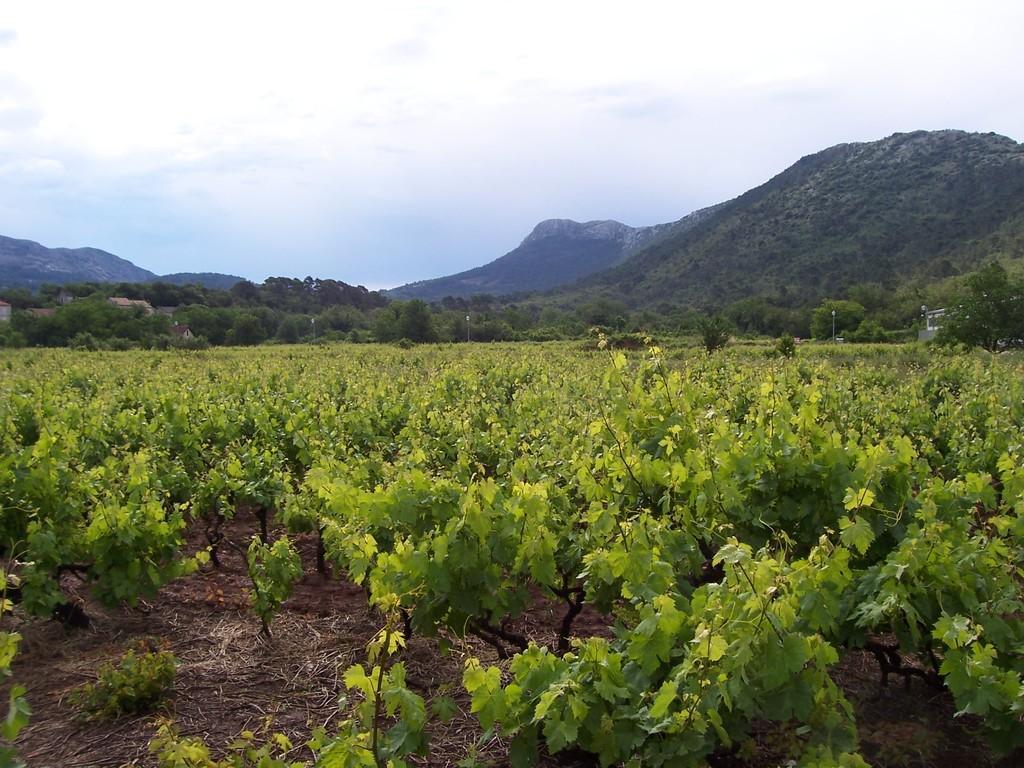How would you summarize this image in a sentence or two? In this picture we can see few plants, trees and hills, and also we can see clouds. 